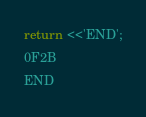<code> <loc_0><loc_0><loc_500><loc_500><_Perl_>

return <<'END';
0F2B		
END
</code> 